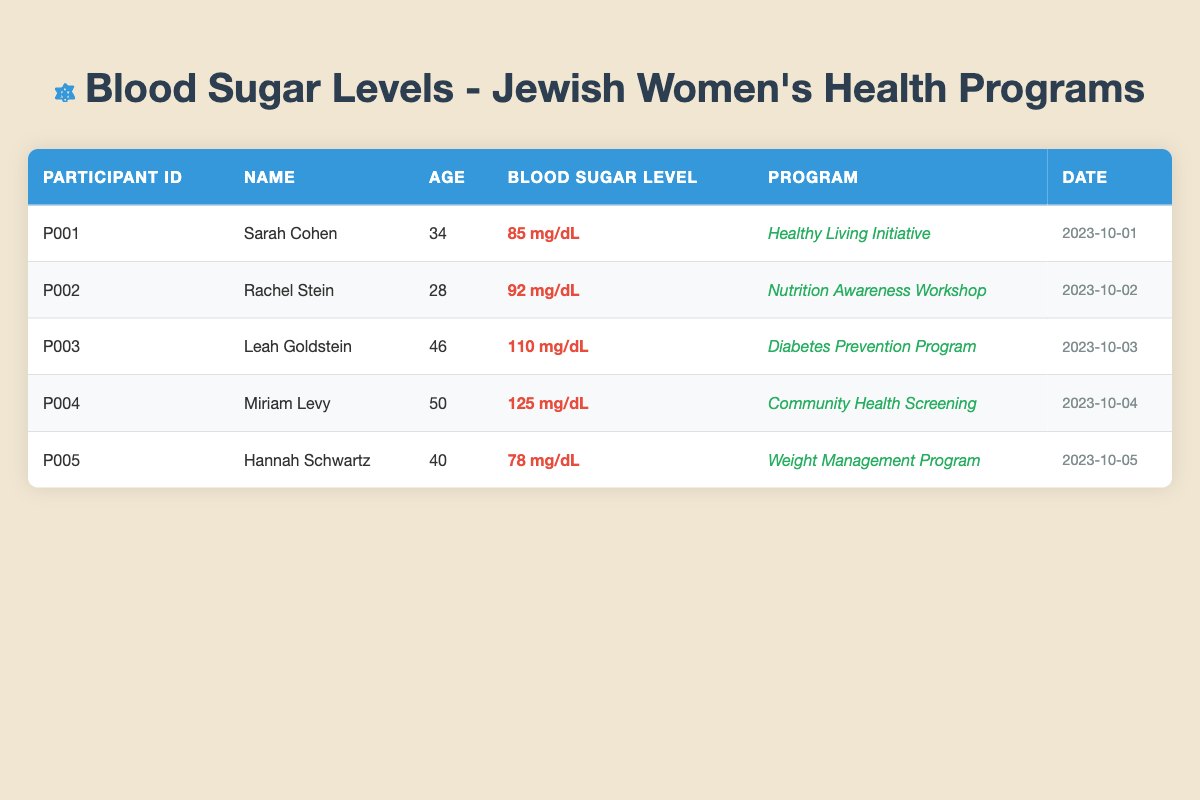What is the blood sugar level of Leah Goldstein? In the table, Leah Goldstein's blood sugar level is listed under the "Blood Sugar Level" column next to her name in the "Name" column. It indicates that her blood sugar level is 110 mg/dL.
Answer: 110 mg/dL Which participant attended the "Weight Management Program"? By scanning the table, I can see that the participant listed under the "Program" column as "Weight Management Program" is Hannah Schwartz.
Answer: Hannah Schwartz What is the average blood sugar level of all participants? To calculate the average blood sugar level, first, sum the individual blood sugar levels: (85 + 92 + 110 + 125 + 78) = 490 mg/dL. Since there are 5 participants, divide the total by 5: 490 / 5 = 98 mg/dL.
Answer: 98 mg/dL Is Miriam Levy younger than 45 years old? Miriam Levy's age is listed as 50 years, which is not younger than 45 years, therefore the statement is false.
Answer: No How many participants have blood sugar levels above 100 mg/dL? Assess the blood sugar levels in the table: Leah Goldstein (110 mg/dL) and Miriam Levy (125 mg/dL) both have levels above 100 mg/dL. Thus, there are two participants that fit this criterion.
Answer: 2 What percentage of participants are part of the "Healthy Living Initiative"? There is a total of 5 participants, and 1 participant (Sarah Cohen) is in the "Healthy Living Initiative". To find the percentage, use the formula: (1 / 5) * 100 = 20%.
Answer: 20% What is the blood sugar difference between Hannah Schwartz and Rachel Stein? Hannah Schwartz has a blood sugar level of 78 mg/dL, while Rachel Stein has a level of 92 mg/dL. To find the difference, subtract Hannah's level from Rachel's: 92 - 78 = 14 mg/dL.
Answer: 14 mg/dL Which program had the highest recorded blood sugar level? The programs listed for participants with the highest blood sugar level belong to Miriam Levy (125 mg/dL) and she is part of the "Community Health Screening". This is the program with the highest recorded blood sugar level in the table.
Answer: Community Health Screening Is there a participant aged 28 years? By checking the ages in the table, Rachel Stein is listed with an age of 28 years, confirming that there is indeed a participant of that age.
Answer: Yes 